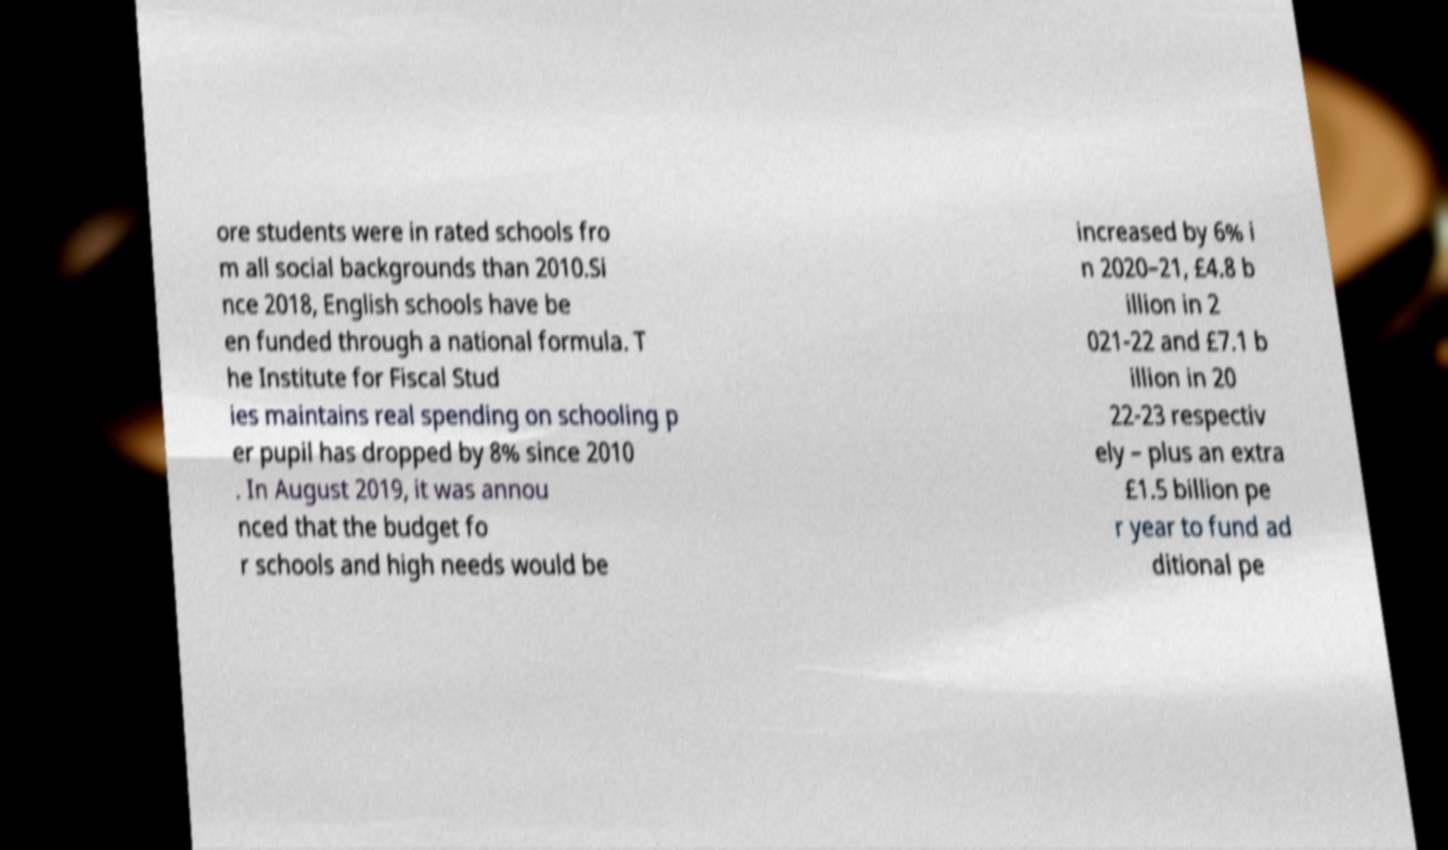Can you accurately transcribe the text from the provided image for me? ore students were in rated schools fro m all social backgrounds than 2010.Si nce 2018, English schools have be en funded through a national formula. T he Institute for Fiscal Stud ies maintains real spending on schooling p er pupil has dropped by 8% since 2010 . In August 2019, it was annou nced that the budget fo r schools and high needs would be increased by 6% i n 2020–21, £4.8 b illion in 2 021-22 and £7.1 b illion in 20 22-23 respectiv ely – plus an extra £1.5 billion pe r year to fund ad ditional pe 